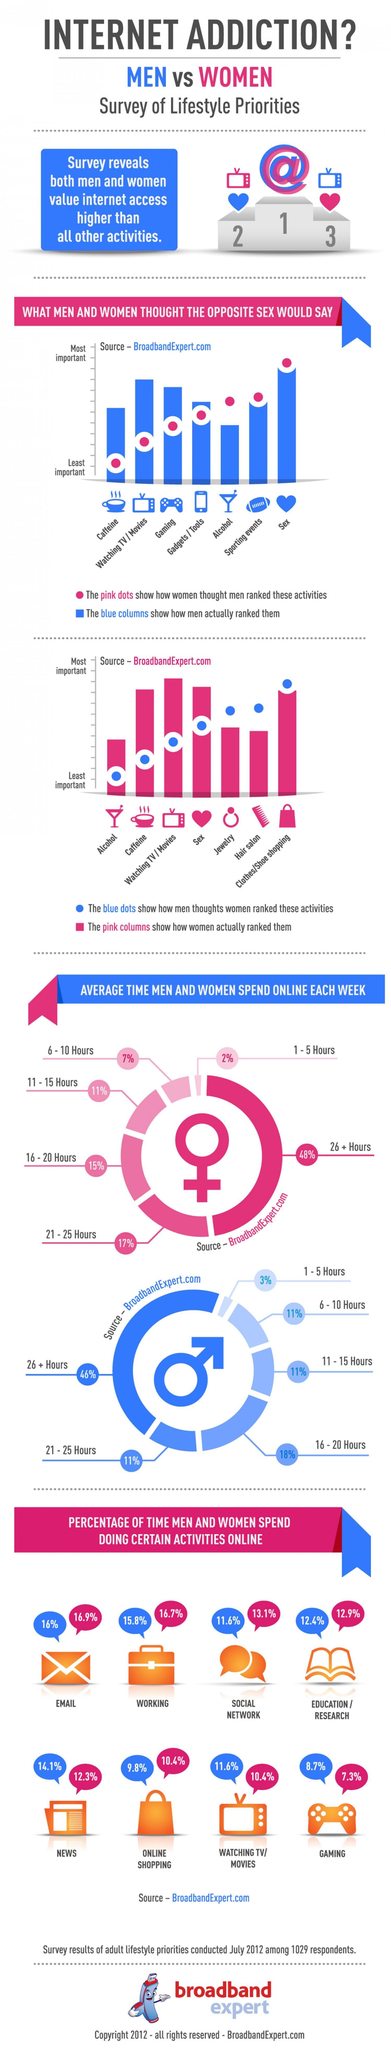What % of time do men spend online for education / research
Answer the question with a short phrase. 12.4% What did men rank the most important activity for women Clothes/shoe shopping Jewelry is a priority for females more than what other activities as per female survey alcohol, hair salon Which are the activities where males spend less than 10% of their time online shopping, gaming which is the online activity which is least popular for both males and females gaming Which activity did women rank very high, but came in the lowest priority when men ranked it alcohol What was ranked as the highest priority by both the sexes Sex WHich are the online activities where both sexes spend more than 15% of their time email, working 